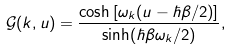Convert formula to latex. <formula><loc_0><loc_0><loc_500><loc_500>\mathcal { G } ( k , u ) = \frac { \cosh \left [ \omega _ { k } ( u - \hbar { \beta } / 2 ) \right ] } { \sinh ( \hbar { \beta } \omega _ { k } / 2 ) } ,</formula> 